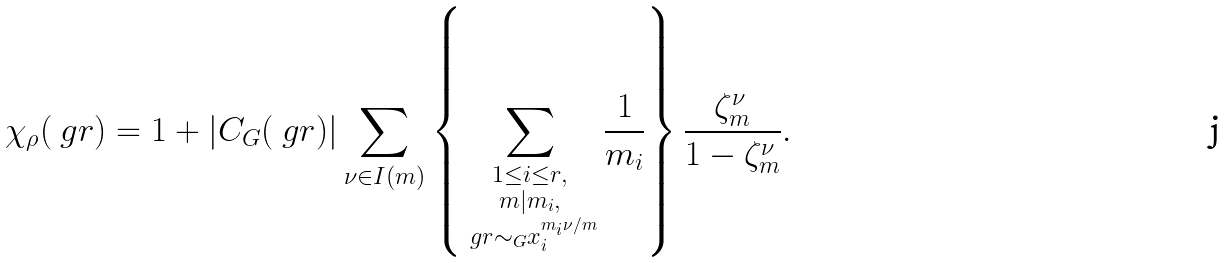<formula> <loc_0><loc_0><loc_500><loc_500>\chi _ { \rho } ( \ g r ) = 1 + | C _ { G } ( \ g r ) | \sum _ { \nu \in I ( m ) } \left \{ \sum _ { \substack { 1 \leq i \leq r , \\ m | m _ { i } , \\ \ g r \sim _ { G } x _ { i } ^ { m _ { i } \nu / m } } } \frac { 1 } { m _ { i } } \right \} \frac { \zeta _ { m } ^ { \nu } } { 1 - \zeta _ { m } ^ { \nu } } .</formula> 